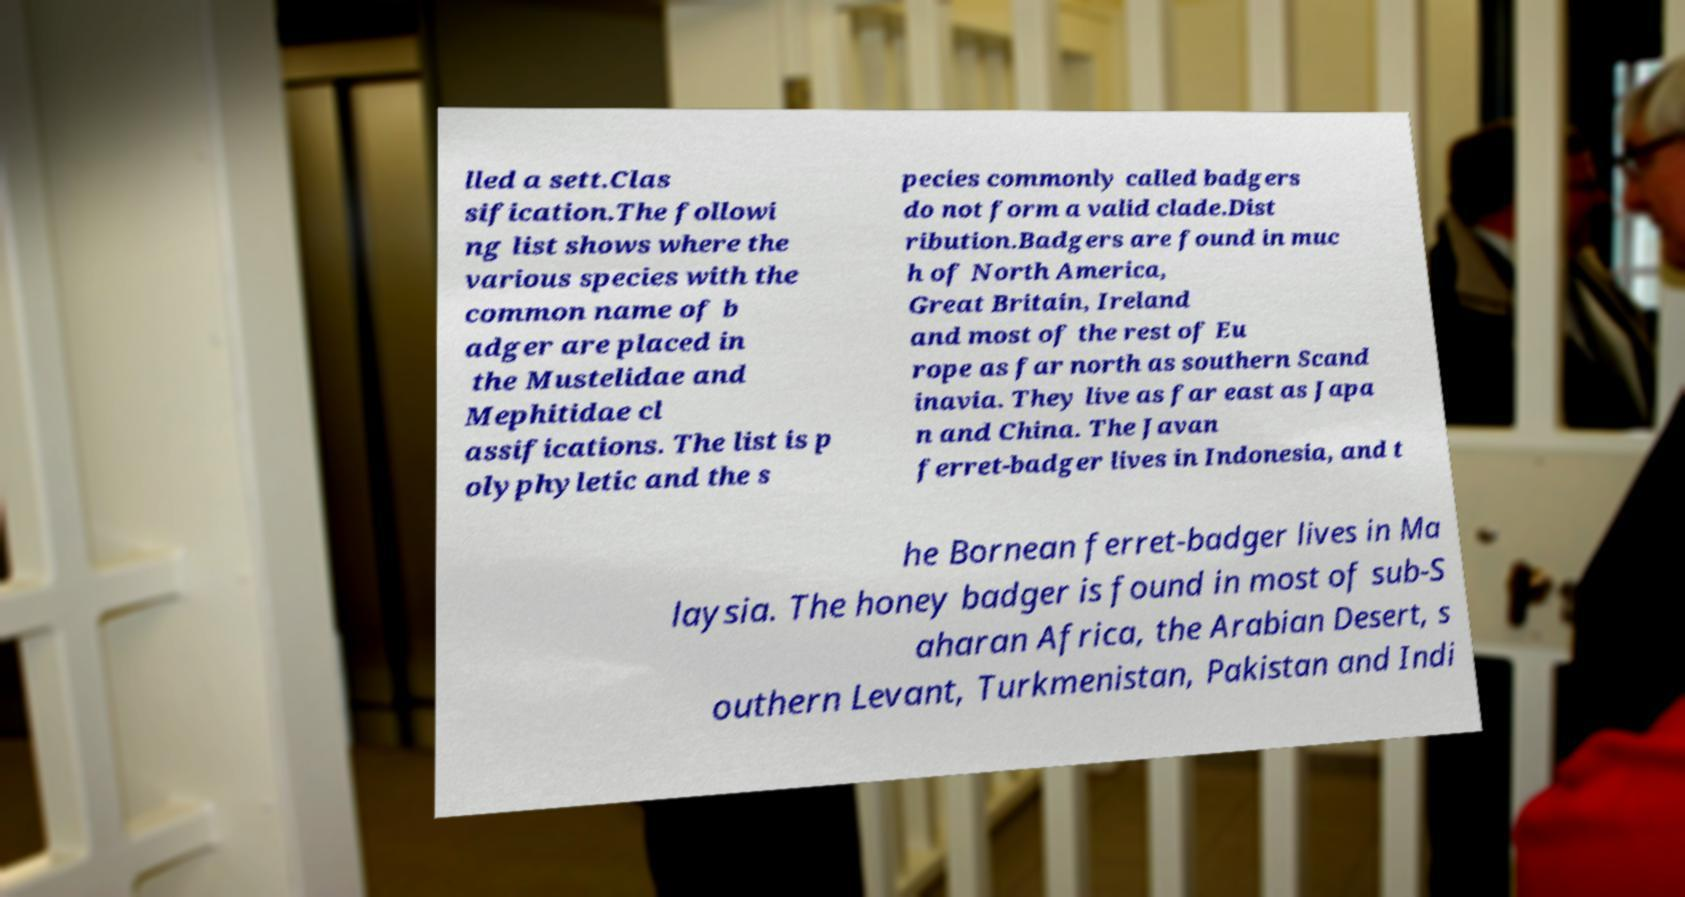Could you assist in decoding the text presented in this image and type it out clearly? lled a sett.Clas sification.The followi ng list shows where the various species with the common name of b adger are placed in the Mustelidae and Mephitidae cl assifications. The list is p olyphyletic and the s pecies commonly called badgers do not form a valid clade.Dist ribution.Badgers are found in muc h of North America, Great Britain, Ireland and most of the rest of Eu rope as far north as southern Scand inavia. They live as far east as Japa n and China. The Javan ferret-badger lives in Indonesia, and t he Bornean ferret-badger lives in Ma laysia. The honey badger is found in most of sub-S aharan Africa, the Arabian Desert, s outhern Levant, Turkmenistan, Pakistan and Indi 